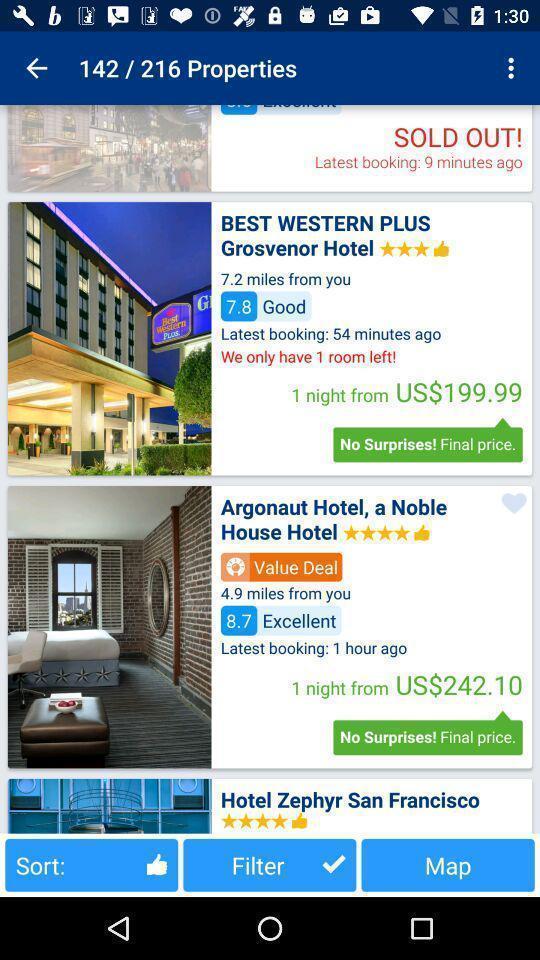What details can you identify in this image? Page showing list of suggestions on an app. 